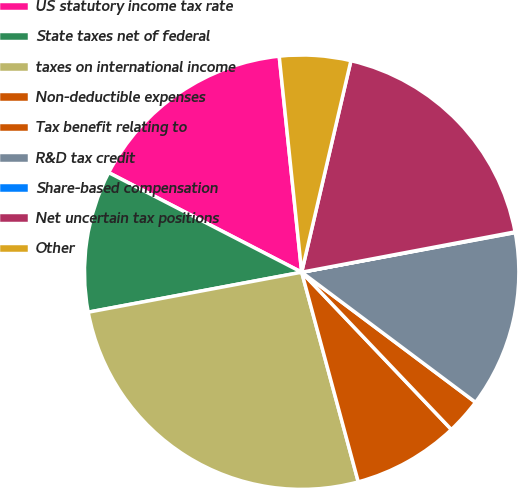<chart> <loc_0><loc_0><loc_500><loc_500><pie_chart><fcel>US statutory income tax rate<fcel>State taxes net of federal<fcel>taxes on international income<fcel>Non-deductible expenses<fcel>Tax benefit relating to<fcel>R&D tax credit<fcel>Share-based compensation<fcel>Net uncertain tax positions<fcel>Other<nl><fcel>15.77%<fcel>10.53%<fcel>26.25%<fcel>7.91%<fcel>2.67%<fcel>13.15%<fcel>0.05%<fcel>18.39%<fcel>5.29%<nl></chart> 